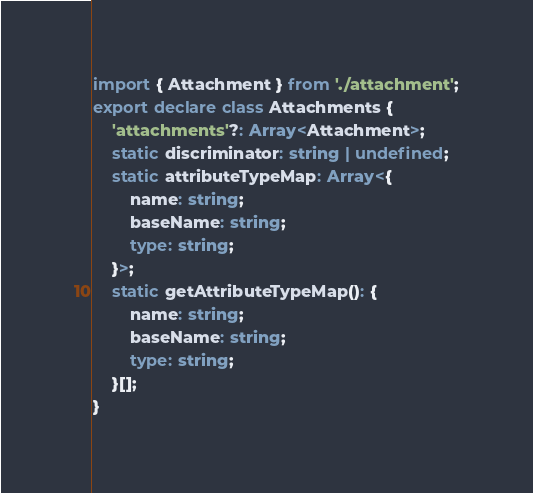<code> <loc_0><loc_0><loc_500><loc_500><_TypeScript_>import { Attachment } from './attachment';
export declare class Attachments {
    'attachments'?: Array<Attachment>;
    static discriminator: string | undefined;
    static attributeTypeMap: Array<{
        name: string;
        baseName: string;
        type: string;
    }>;
    static getAttributeTypeMap(): {
        name: string;
        baseName: string;
        type: string;
    }[];
}
</code> 